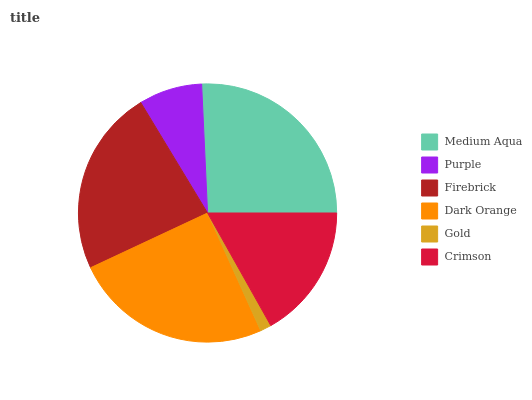Is Gold the minimum?
Answer yes or no. Yes. Is Medium Aqua the maximum?
Answer yes or no. Yes. Is Purple the minimum?
Answer yes or no. No. Is Purple the maximum?
Answer yes or no. No. Is Medium Aqua greater than Purple?
Answer yes or no. Yes. Is Purple less than Medium Aqua?
Answer yes or no. Yes. Is Purple greater than Medium Aqua?
Answer yes or no. No. Is Medium Aqua less than Purple?
Answer yes or no. No. Is Firebrick the high median?
Answer yes or no. Yes. Is Crimson the low median?
Answer yes or no. Yes. Is Purple the high median?
Answer yes or no. No. Is Dark Orange the low median?
Answer yes or no. No. 